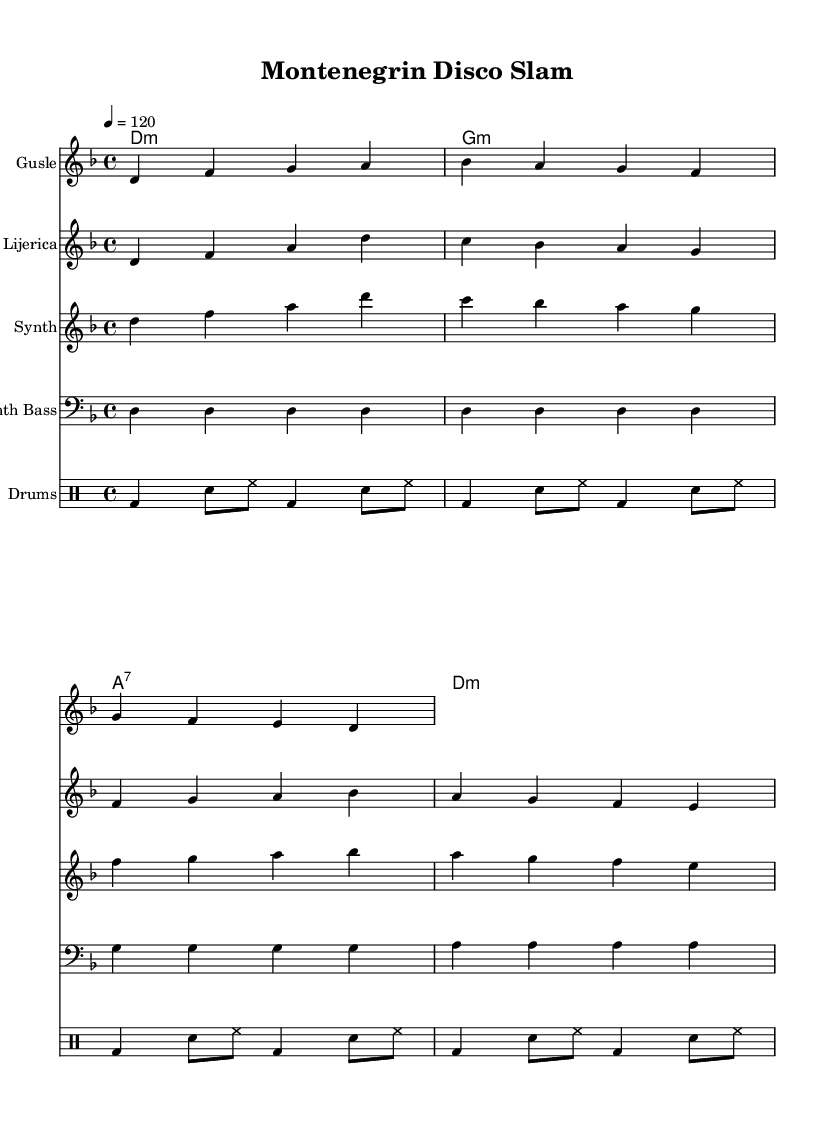What is the key signature of this music? The key signature is indicated by the absence of sharps or flats and is placed at the beginning of the staff. It corresponds to D minor, which has one flat.
Answer: D minor What is the time signature of this music? The time signature is indicated at the beginning of the staff, showing how many beats are in a measure and what note gets one beat. Here it shows 4 beats per measure with the quarter note receiving one beat.
Answer: 4/4 What is the tempo marking for this piece? The tempo marking is found in standard notation at the start of the score, specifying the speed of the piece. It indicates that the piece should be played at 120 beats per minute.
Answer: 120 How many instruments are featured in this score? The score features multiple staves, each indicating a different instrument. By counting the individual staves, we find there are five distinct instruments: gusle, lijerica, synth, synth bass, and drums.
Answer: Five Which chord is played at the beginning of the guitar section? The chord shown in the chord mode at the beginning of the piece indicates the harmony that underlies the instrumental parts. The first chord is a D minor chord.
Answer: D minor What type of drums is primarily used in this piece? The drum notation, marked in a specific format, outlines the types of beats included. The bass drum appears prominently at the start of each measure, indicating it is the primary rhythm component.
Answer: Bass drum Which traditional instrument is used in this score? The instrument names are indicated on each staff. The gusle is specifically a traditional Montenegrin string instrument featured in this score.
Answer: Gusle 